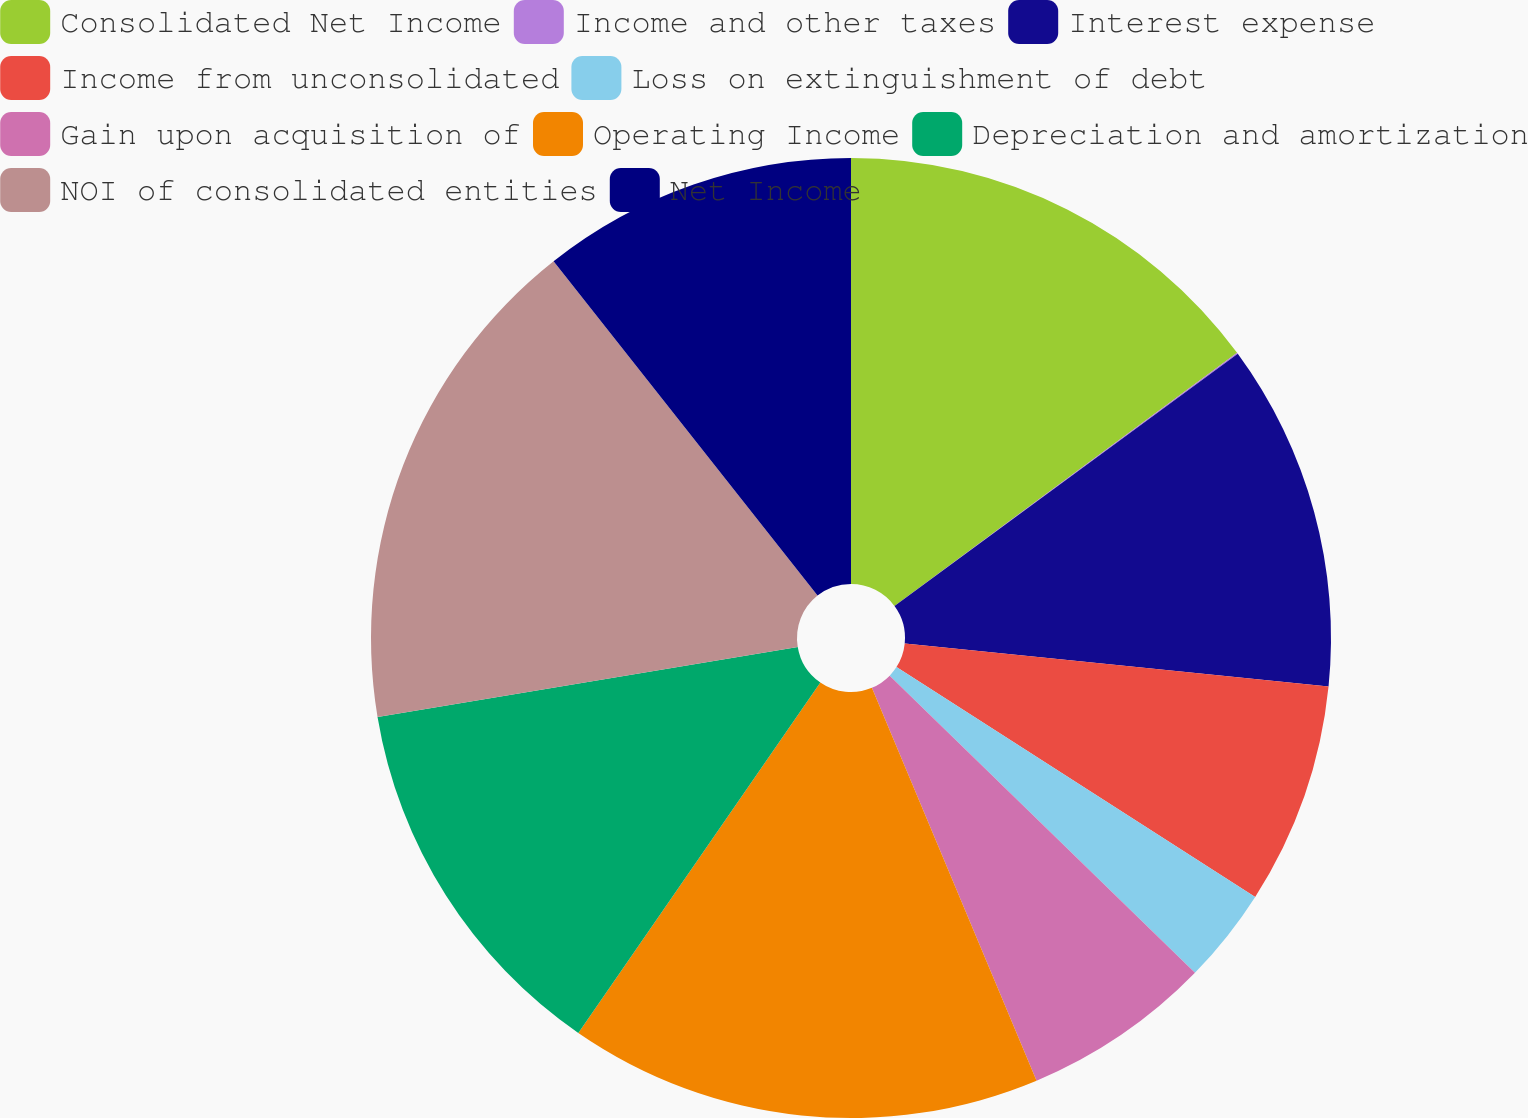<chart> <loc_0><loc_0><loc_500><loc_500><pie_chart><fcel>Consolidated Net Income<fcel>Income and other taxes<fcel>Interest expense<fcel>Income from unconsolidated<fcel>Loss on extinguishment of debt<fcel>Gain upon acquisition of<fcel>Operating Income<fcel>Depreciation and amortization<fcel>NOI of consolidated entities<fcel>Net Income<nl><fcel>14.88%<fcel>0.04%<fcel>11.7%<fcel>7.46%<fcel>3.22%<fcel>6.4%<fcel>15.94%<fcel>12.76%<fcel>17.0%<fcel>10.64%<nl></chart> 